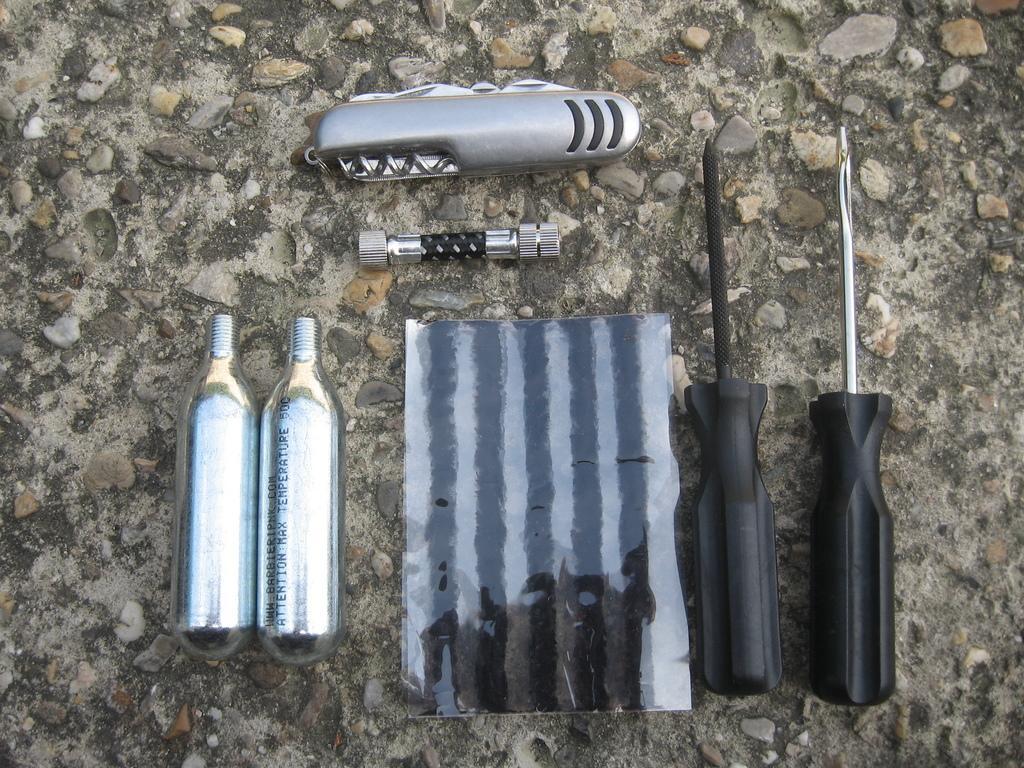Describe this image in one or two sentences. In the image there are screwdrivers,metal piece,cutting tool,bolt,nut and two fixtures on the floor. 